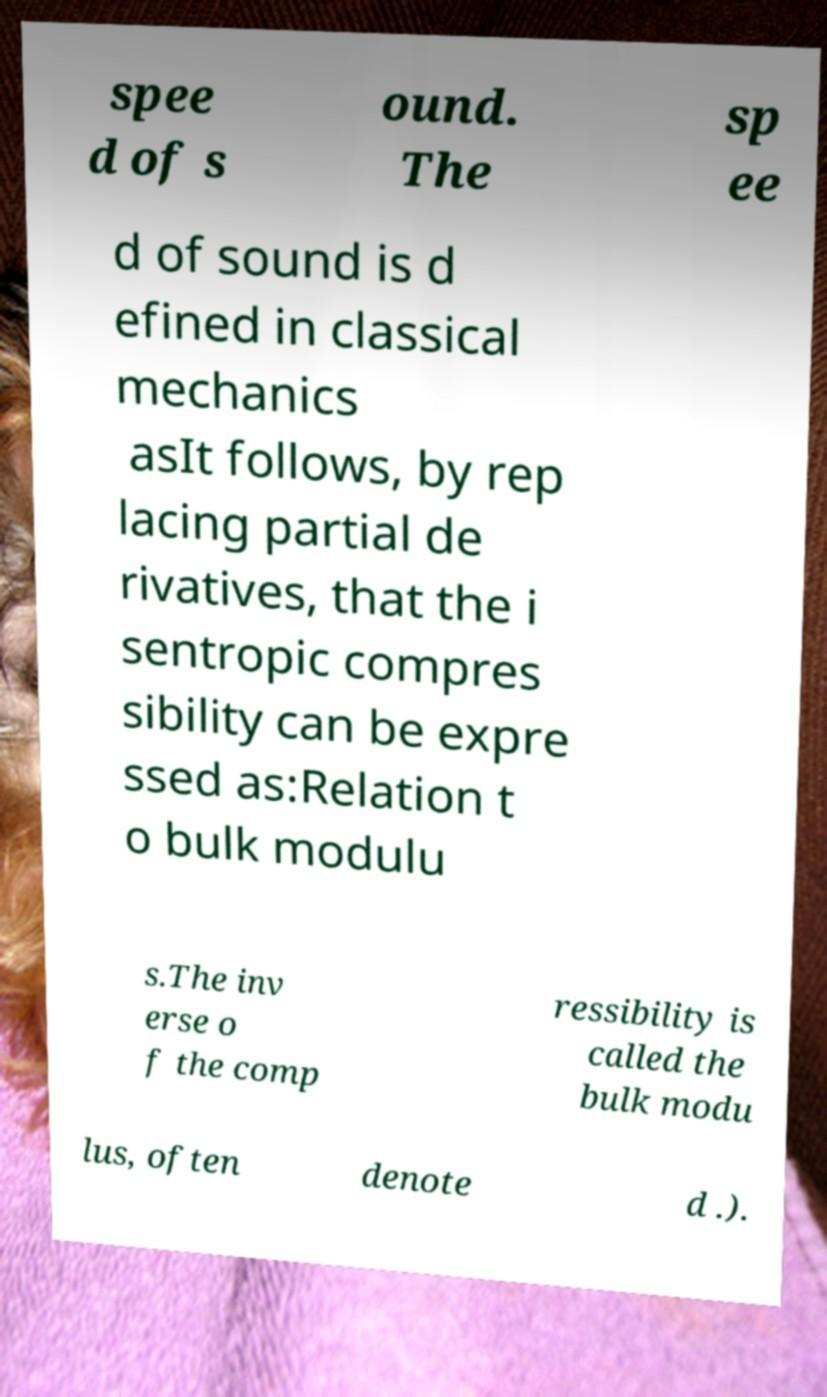I need the written content from this picture converted into text. Can you do that? spee d of s ound. The sp ee d of sound is d efined in classical mechanics asIt follows, by rep lacing partial de rivatives, that the i sentropic compres sibility can be expre ssed as:Relation t o bulk modulu s.The inv erse o f the comp ressibility is called the bulk modu lus, often denote d .). 